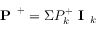Convert formula to latex. <formula><loc_0><loc_0><loc_500><loc_500>P ^ { + } = \Sigma P _ { k } ^ { + } I _ { k }</formula> 